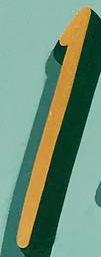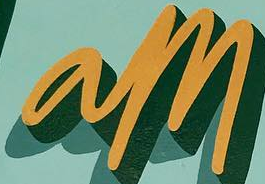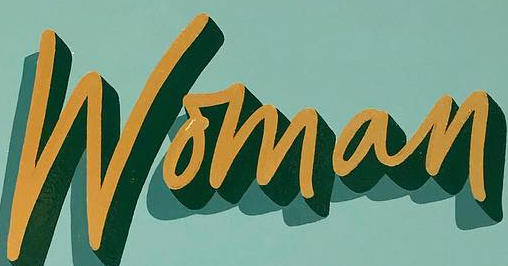Transcribe the words shown in these images in order, separated by a semicolon. I; am; Woman 